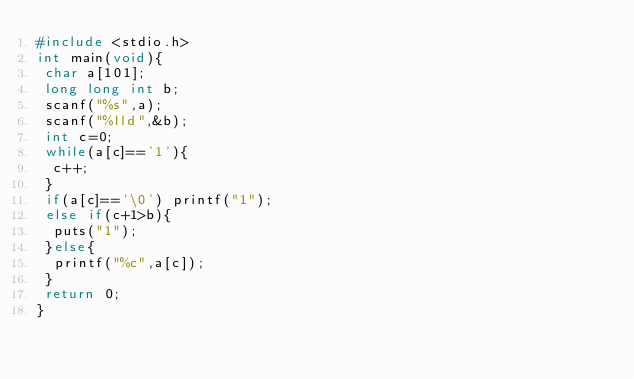<code> <loc_0><loc_0><loc_500><loc_500><_C_>#include <stdio.h>
int main(void){
 char a[101];
 long long int b;
 scanf("%s",a);
 scanf("%lld",&b);
 int c=0;
 while(a[c]=='1'){
  c++;
 }
 if(a[c]=='\0') printf("1");
 else if(c+1>b){
  puts("1");
 }else{
  printf("%c",a[c]);
 }
 return 0;
}
</code> 